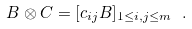Convert formula to latex. <formula><loc_0><loc_0><loc_500><loc_500>B \otimes C = [ c _ { i j } B ] _ { 1 \leq i , j \leq m } \ .</formula> 